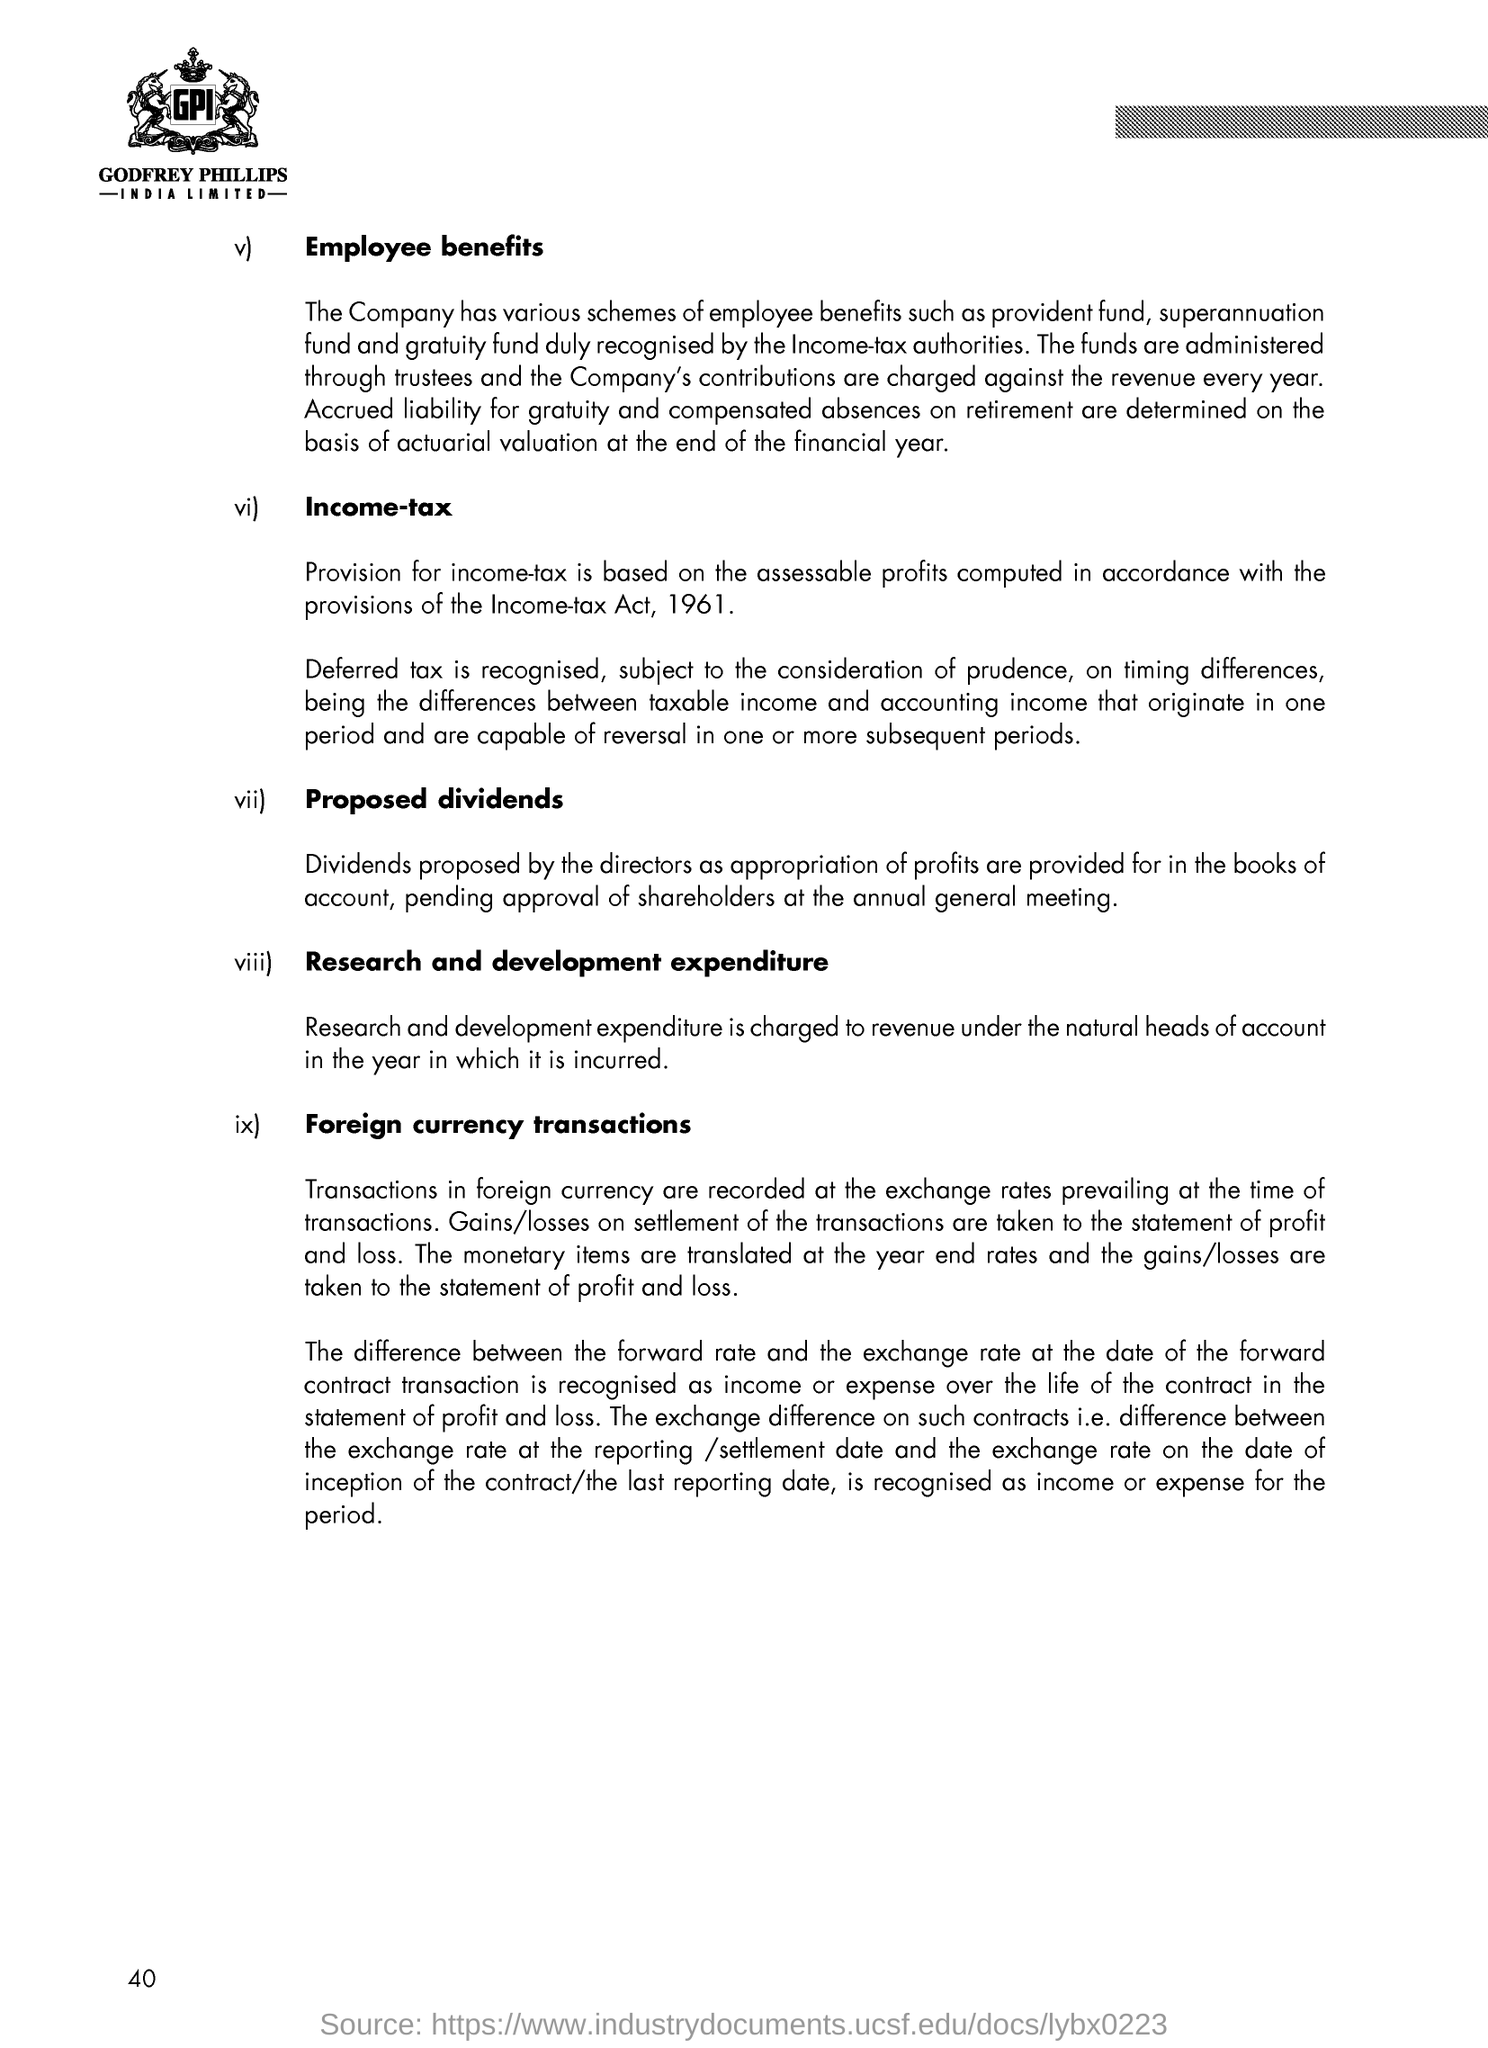Describe the process for foreign currency transactions as mentioned in the document. According to the document, transactions in foreign currency are recorded at exchange rates prevailing at the time of the transactions. Any gains or losses upon settlement are reflected in the statement of profit and loss. Monetary items are translated at year-end exchange rates, and any resulting gains or losses are also taken to the statement of profit and loss. It also details the treatment of exchange differences on forward contracts and other related transactions over their lifecycle and at reporting dates. 